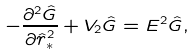<formula> <loc_0><loc_0><loc_500><loc_500>- \frac { \partial ^ { 2 } \hat { G } } { \partial \hat { r } _ { \ast } ^ { 2 } } + V _ { 2 } \hat { G } = E ^ { 2 } \hat { G } ,</formula> 